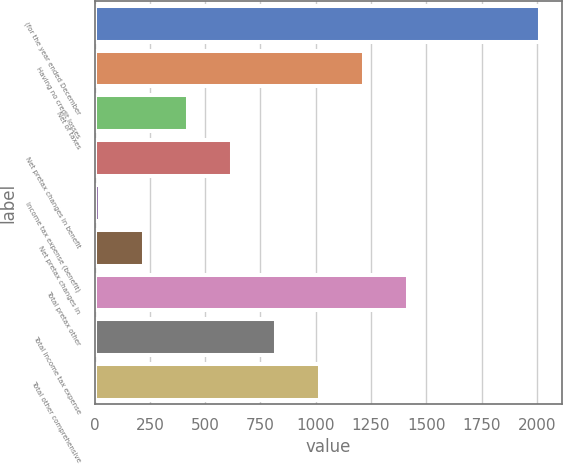Convert chart to OTSL. <chart><loc_0><loc_0><loc_500><loc_500><bar_chart><fcel>(for the year ended December<fcel>Having no credit losses<fcel>Net of taxes<fcel>Net pretax changes in benefit<fcel>Income tax expense (benefit)<fcel>Net pretax changes in<fcel>Total pretax other<fcel>Total income tax expense<fcel>Total other comprehensive<nl><fcel>2012<fcel>1216.4<fcel>420.8<fcel>619.7<fcel>23<fcel>221.9<fcel>1415.3<fcel>818.6<fcel>1017.5<nl></chart> 